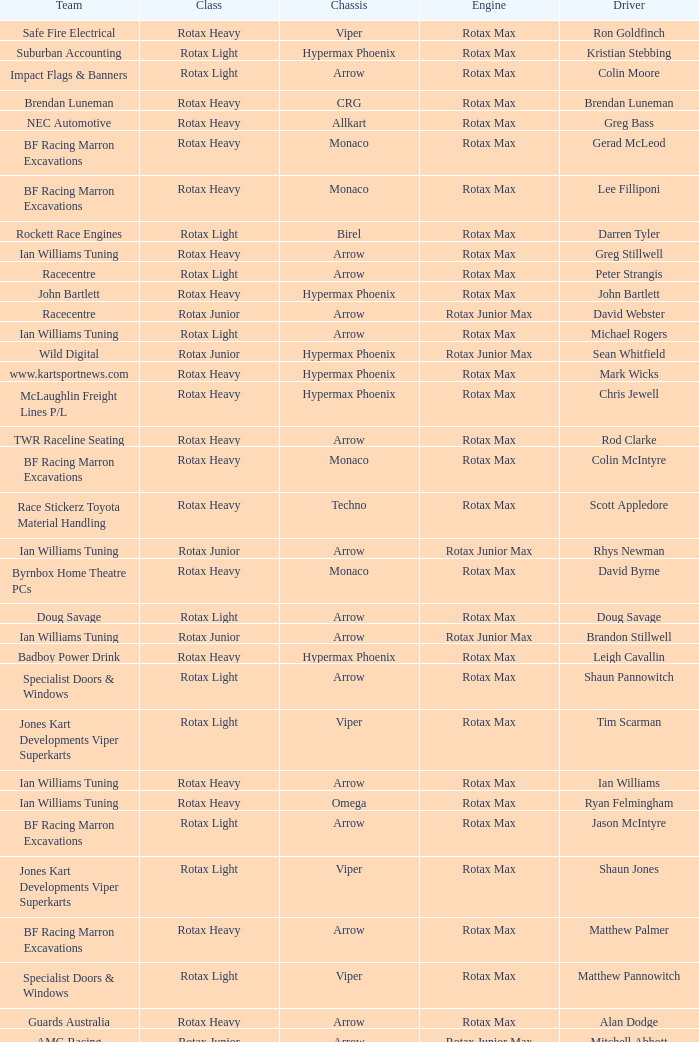Driver Shaun Jones with a viper as a chassis is in what class? Rotax Light. 